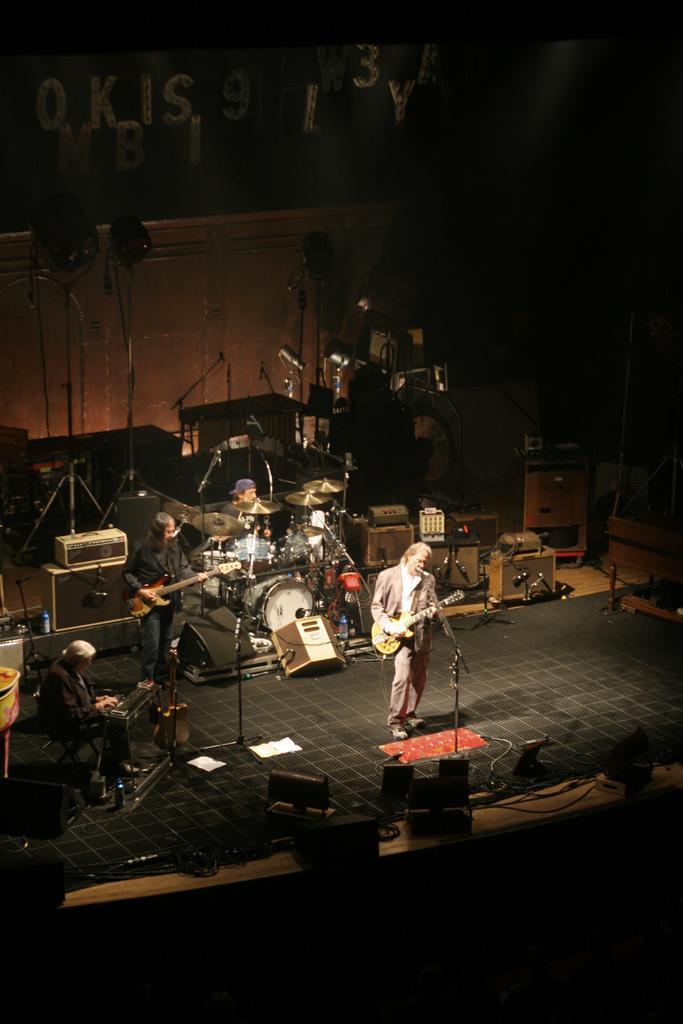Describe this image in one or two sentences. In this image we can see a few people playing musical instruments on the stage and there is a person standing and holding a guitar and singing and there is a mic in front of him. There are some stage lights, speakers and some other objects on the stage. 